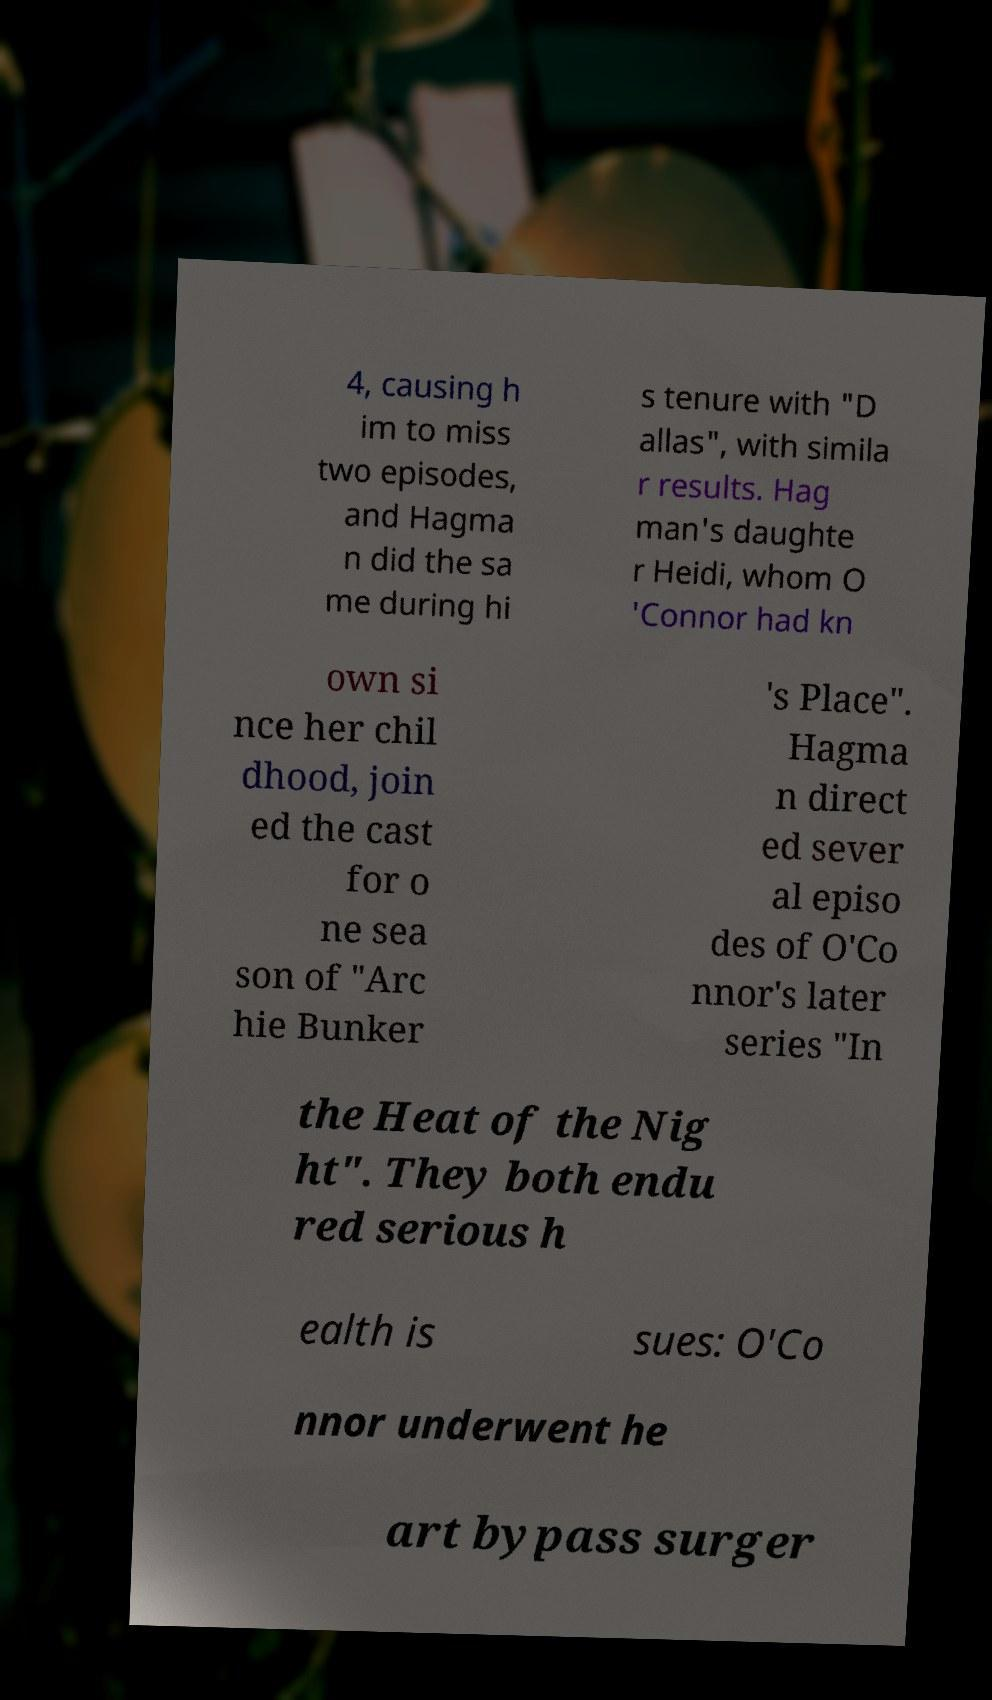Please identify and transcribe the text found in this image. 4, causing h im to miss two episodes, and Hagma n did the sa me during hi s tenure with "D allas", with simila r results. Hag man's daughte r Heidi, whom O 'Connor had kn own si nce her chil dhood, join ed the cast for o ne sea son of "Arc hie Bunker 's Place". Hagma n direct ed sever al episo des of O'Co nnor's later series "In the Heat of the Nig ht". They both endu red serious h ealth is sues: O'Co nnor underwent he art bypass surger 